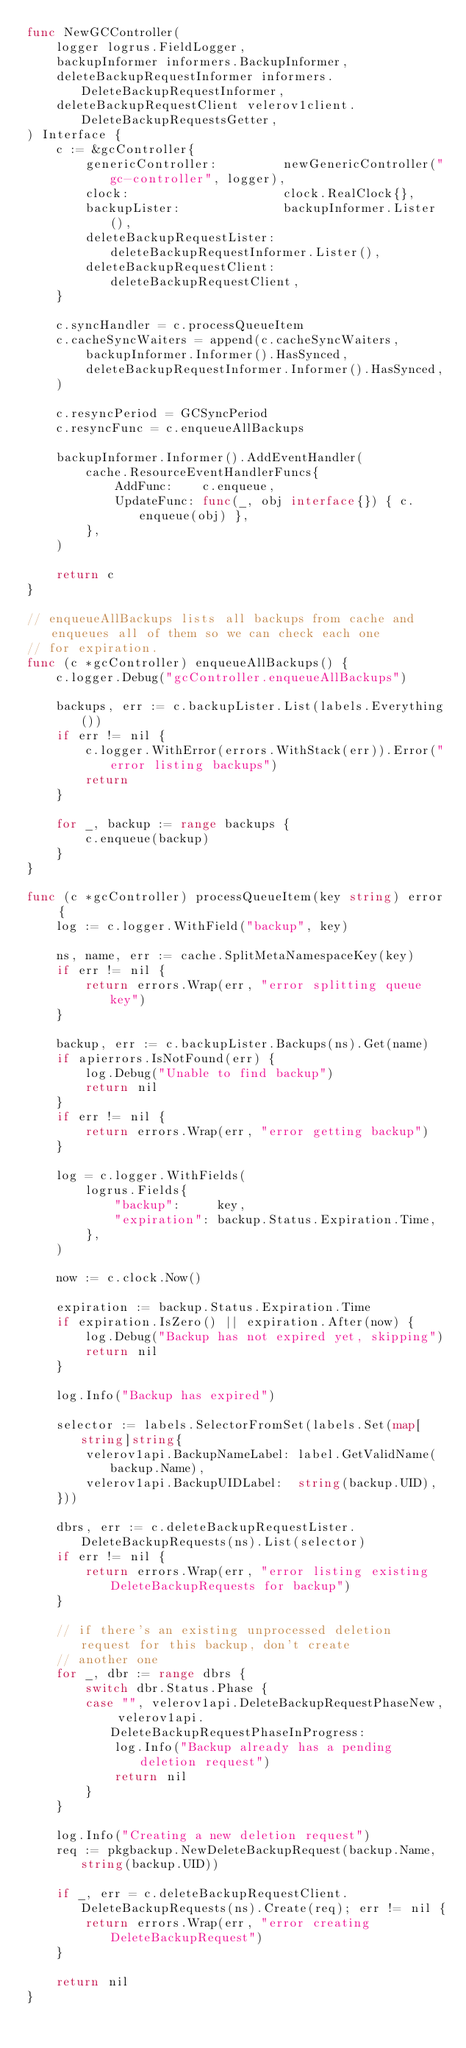Convert code to text. <code><loc_0><loc_0><loc_500><loc_500><_Go_>func NewGCController(
	logger logrus.FieldLogger,
	backupInformer informers.BackupInformer,
	deleteBackupRequestInformer informers.DeleteBackupRequestInformer,
	deleteBackupRequestClient velerov1client.DeleteBackupRequestsGetter,
) Interface {
	c := &gcController{
		genericController:         newGenericController("gc-controller", logger),
		clock:                     clock.RealClock{},
		backupLister:              backupInformer.Lister(),
		deleteBackupRequestLister: deleteBackupRequestInformer.Lister(),
		deleteBackupRequestClient: deleteBackupRequestClient,
	}

	c.syncHandler = c.processQueueItem
	c.cacheSyncWaiters = append(c.cacheSyncWaiters,
		backupInformer.Informer().HasSynced,
		deleteBackupRequestInformer.Informer().HasSynced,
	)

	c.resyncPeriod = GCSyncPeriod
	c.resyncFunc = c.enqueueAllBackups

	backupInformer.Informer().AddEventHandler(
		cache.ResourceEventHandlerFuncs{
			AddFunc:    c.enqueue,
			UpdateFunc: func(_, obj interface{}) { c.enqueue(obj) },
		},
	)

	return c
}

// enqueueAllBackups lists all backups from cache and enqueues all of them so we can check each one
// for expiration.
func (c *gcController) enqueueAllBackups() {
	c.logger.Debug("gcController.enqueueAllBackups")

	backups, err := c.backupLister.List(labels.Everything())
	if err != nil {
		c.logger.WithError(errors.WithStack(err)).Error("error listing backups")
		return
	}

	for _, backup := range backups {
		c.enqueue(backup)
	}
}

func (c *gcController) processQueueItem(key string) error {
	log := c.logger.WithField("backup", key)

	ns, name, err := cache.SplitMetaNamespaceKey(key)
	if err != nil {
		return errors.Wrap(err, "error splitting queue key")
	}

	backup, err := c.backupLister.Backups(ns).Get(name)
	if apierrors.IsNotFound(err) {
		log.Debug("Unable to find backup")
		return nil
	}
	if err != nil {
		return errors.Wrap(err, "error getting backup")
	}

	log = c.logger.WithFields(
		logrus.Fields{
			"backup":     key,
			"expiration": backup.Status.Expiration.Time,
		},
	)

	now := c.clock.Now()

	expiration := backup.Status.Expiration.Time
	if expiration.IsZero() || expiration.After(now) {
		log.Debug("Backup has not expired yet, skipping")
		return nil
	}

	log.Info("Backup has expired")

	selector := labels.SelectorFromSet(labels.Set(map[string]string{
		velerov1api.BackupNameLabel: label.GetValidName(backup.Name),
		velerov1api.BackupUIDLabel:  string(backup.UID),
	}))

	dbrs, err := c.deleteBackupRequestLister.DeleteBackupRequests(ns).List(selector)
	if err != nil {
		return errors.Wrap(err, "error listing existing DeleteBackupRequests for backup")
	}

	// if there's an existing unprocessed deletion request for this backup, don't create
	// another one
	for _, dbr := range dbrs {
		switch dbr.Status.Phase {
		case "", velerov1api.DeleteBackupRequestPhaseNew, velerov1api.DeleteBackupRequestPhaseInProgress:
			log.Info("Backup already has a pending deletion request")
			return nil
		}
	}

	log.Info("Creating a new deletion request")
	req := pkgbackup.NewDeleteBackupRequest(backup.Name, string(backup.UID))

	if _, err = c.deleteBackupRequestClient.DeleteBackupRequests(ns).Create(req); err != nil {
		return errors.Wrap(err, "error creating DeleteBackupRequest")
	}

	return nil
}
</code> 